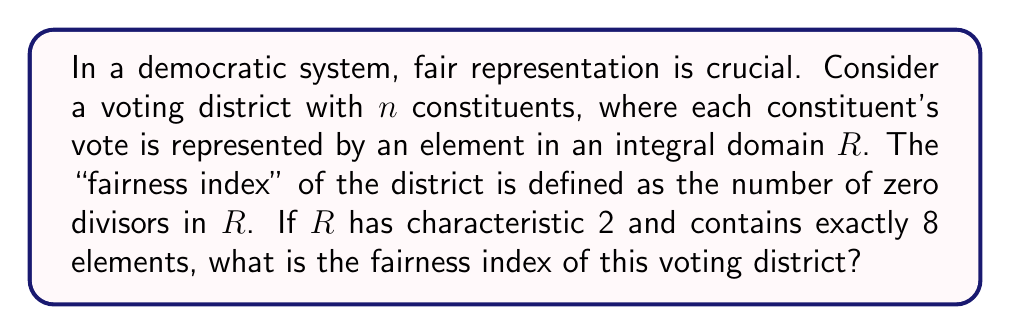Solve this math problem. Let's approach this step-by-step:

1) An integral domain is a commutative ring with unity and no zero divisors. This means that if $ab = 0$ for $a, b \in R$, then either $a = 0$ or $b = 0$.

2) The characteristic of a ring is the smallest positive integer $n$ such that $n \cdot 1 = 0$ in the ring. If no such $n$ exists, the ring has characteristic 0. Here, the characteristic is 2, so $1 + 1 = 0$ in $R$.

3) We're told that $R$ has exactly 8 elements. The only finite integral domain with 8 elements is the field $\mathbb{F}_8$, which is a finite field of order 8.

4) $\mathbb{F}_8$ can be constructed as $\mathbb{F}_2[x]/(x^3 + x + 1)$, where $\mathbb{F}_2$ is the field with two elements and $(x^3 + x + 1)$ is the ideal generated by the irreducible polynomial $x^3 + x + 1$ over $\mathbb{F}_2$.

5) The elements of $\mathbb{F}_8$ are: $\{0, 1, \alpha, \alpha^2, 1+\alpha, 1+\alpha^2, \alpha+\alpha^2, 1+\alpha+\alpha^2\}$, where $\alpha$ is a root of $x^3 + x + 1$.

6) In a field, the only zero divisor is 0 itself. This is because fields have multiplicative inverses for all non-zero elements.

7) Therefore, the "fairness index" of this voting district, which is defined as the number of zero divisors in $R$, is 1 (only the element 0 is a zero divisor).
Answer: The fairness index of the voting district is 1. 